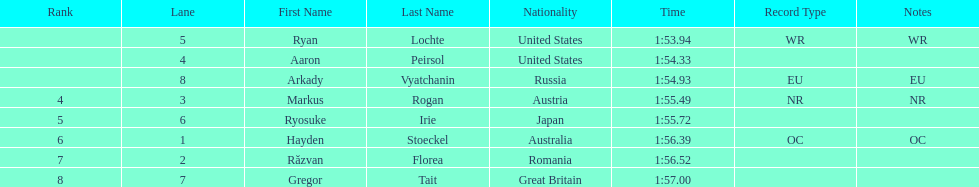Did austria or russia rank higher? Russia. 